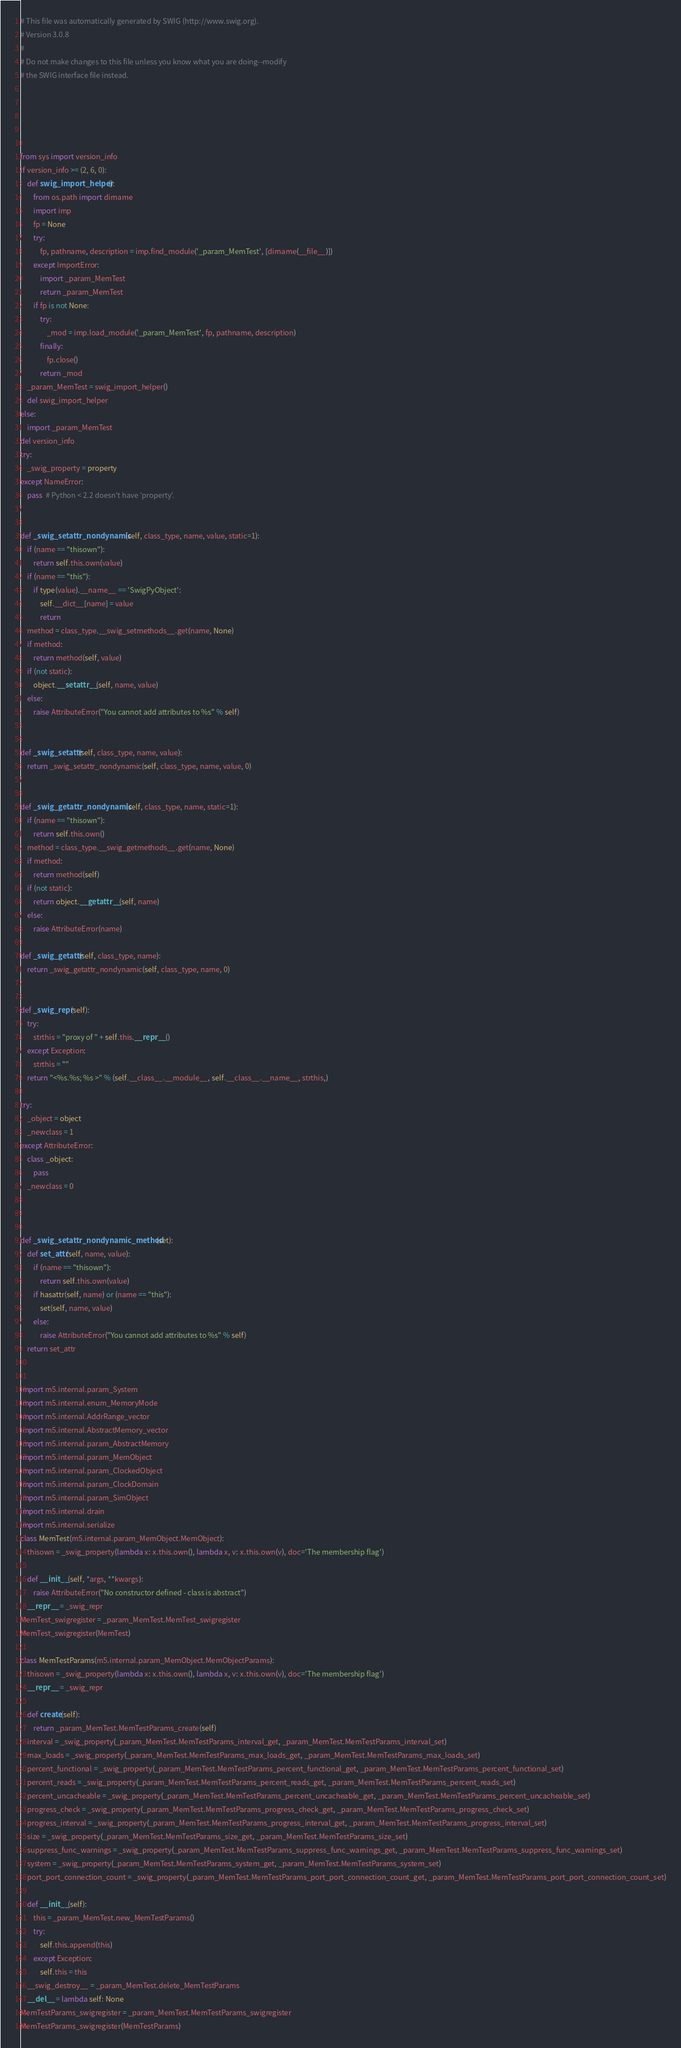Convert code to text. <code><loc_0><loc_0><loc_500><loc_500><_Python_># This file was automatically generated by SWIG (http://www.swig.org).
# Version 3.0.8
#
# Do not make changes to this file unless you know what you are doing--modify
# the SWIG interface file instead.





from sys import version_info
if version_info >= (2, 6, 0):
    def swig_import_helper():
        from os.path import dirname
        import imp
        fp = None
        try:
            fp, pathname, description = imp.find_module('_param_MemTest', [dirname(__file__)])
        except ImportError:
            import _param_MemTest
            return _param_MemTest
        if fp is not None:
            try:
                _mod = imp.load_module('_param_MemTest', fp, pathname, description)
            finally:
                fp.close()
            return _mod
    _param_MemTest = swig_import_helper()
    del swig_import_helper
else:
    import _param_MemTest
del version_info
try:
    _swig_property = property
except NameError:
    pass  # Python < 2.2 doesn't have 'property'.


def _swig_setattr_nondynamic(self, class_type, name, value, static=1):
    if (name == "thisown"):
        return self.this.own(value)
    if (name == "this"):
        if type(value).__name__ == 'SwigPyObject':
            self.__dict__[name] = value
            return
    method = class_type.__swig_setmethods__.get(name, None)
    if method:
        return method(self, value)
    if (not static):
        object.__setattr__(self, name, value)
    else:
        raise AttributeError("You cannot add attributes to %s" % self)


def _swig_setattr(self, class_type, name, value):
    return _swig_setattr_nondynamic(self, class_type, name, value, 0)


def _swig_getattr_nondynamic(self, class_type, name, static=1):
    if (name == "thisown"):
        return self.this.own()
    method = class_type.__swig_getmethods__.get(name, None)
    if method:
        return method(self)
    if (not static):
        return object.__getattr__(self, name)
    else:
        raise AttributeError(name)

def _swig_getattr(self, class_type, name):
    return _swig_getattr_nondynamic(self, class_type, name, 0)


def _swig_repr(self):
    try:
        strthis = "proxy of " + self.this.__repr__()
    except Exception:
        strthis = ""
    return "<%s.%s; %s >" % (self.__class__.__module__, self.__class__.__name__, strthis,)

try:
    _object = object
    _newclass = 1
except AttributeError:
    class _object:
        pass
    _newclass = 0



def _swig_setattr_nondynamic_method(set):
    def set_attr(self, name, value):
        if (name == "thisown"):
            return self.this.own(value)
        if hasattr(self, name) or (name == "this"):
            set(self, name, value)
        else:
            raise AttributeError("You cannot add attributes to %s" % self)
    return set_attr


import m5.internal.param_System
import m5.internal.enum_MemoryMode
import m5.internal.AddrRange_vector
import m5.internal.AbstractMemory_vector
import m5.internal.param_AbstractMemory
import m5.internal.param_MemObject
import m5.internal.param_ClockedObject
import m5.internal.param_ClockDomain
import m5.internal.param_SimObject
import m5.internal.drain
import m5.internal.serialize
class MemTest(m5.internal.param_MemObject.MemObject):
    thisown = _swig_property(lambda x: x.this.own(), lambda x, v: x.this.own(v), doc='The membership flag')

    def __init__(self, *args, **kwargs):
        raise AttributeError("No constructor defined - class is abstract")
    __repr__ = _swig_repr
MemTest_swigregister = _param_MemTest.MemTest_swigregister
MemTest_swigregister(MemTest)

class MemTestParams(m5.internal.param_MemObject.MemObjectParams):
    thisown = _swig_property(lambda x: x.this.own(), lambda x, v: x.this.own(v), doc='The membership flag')
    __repr__ = _swig_repr

    def create(self):
        return _param_MemTest.MemTestParams_create(self)
    interval = _swig_property(_param_MemTest.MemTestParams_interval_get, _param_MemTest.MemTestParams_interval_set)
    max_loads = _swig_property(_param_MemTest.MemTestParams_max_loads_get, _param_MemTest.MemTestParams_max_loads_set)
    percent_functional = _swig_property(_param_MemTest.MemTestParams_percent_functional_get, _param_MemTest.MemTestParams_percent_functional_set)
    percent_reads = _swig_property(_param_MemTest.MemTestParams_percent_reads_get, _param_MemTest.MemTestParams_percent_reads_set)
    percent_uncacheable = _swig_property(_param_MemTest.MemTestParams_percent_uncacheable_get, _param_MemTest.MemTestParams_percent_uncacheable_set)
    progress_check = _swig_property(_param_MemTest.MemTestParams_progress_check_get, _param_MemTest.MemTestParams_progress_check_set)
    progress_interval = _swig_property(_param_MemTest.MemTestParams_progress_interval_get, _param_MemTest.MemTestParams_progress_interval_set)
    size = _swig_property(_param_MemTest.MemTestParams_size_get, _param_MemTest.MemTestParams_size_set)
    suppress_func_warnings = _swig_property(_param_MemTest.MemTestParams_suppress_func_warnings_get, _param_MemTest.MemTestParams_suppress_func_warnings_set)
    system = _swig_property(_param_MemTest.MemTestParams_system_get, _param_MemTest.MemTestParams_system_set)
    port_port_connection_count = _swig_property(_param_MemTest.MemTestParams_port_port_connection_count_get, _param_MemTest.MemTestParams_port_port_connection_count_set)

    def __init__(self):
        this = _param_MemTest.new_MemTestParams()
        try:
            self.this.append(this)
        except Exception:
            self.this = this
    __swig_destroy__ = _param_MemTest.delete_MemTestParams
    __del__ = lambda self: None
MemTestParams_swigregister = _param_MemTest.MemTestParams_swigregister
MemTestParams_swigregister(MemTestParams)



</code> 